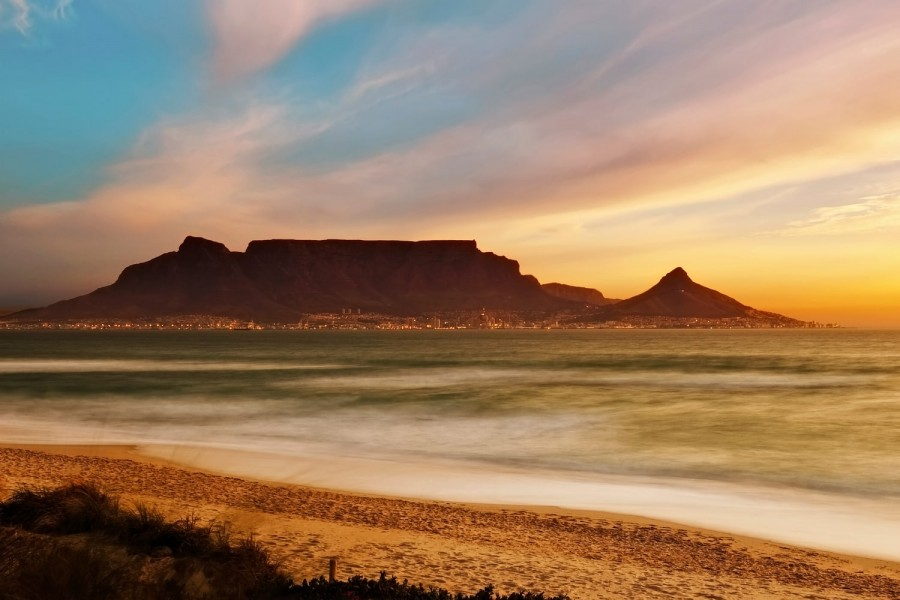What might be the story of the people who left the footprints on the sand? The footprints on the sand tell a quiet, unfolding story of a couple who came to the beach for an evening walk. Hand in hand, they strolled along the shore, talking softly and enjoying each other's company. They were met with the cool, gentle breeze that carried with it the smell of the sea. The man, a photographer, came to capture the sunset as it painted the sky in shades of orange and purple. He paused often, leaving behind deeper impressions in the sand as he set his camera for the perfect shot. The woman, a writer, gathered inspiration from the picturesque scenery and the sounds around her. She occasionally bent down to pick up a unique shell or a smooth stone, contemplating its story as the ocean waves played a soothing symphony. Together, they left a trail of intertwined footprints, a memento of their shared moment amidst the serene beauty of Table Mountain's overlooking presence and the calm ocean.  On a clear day, what might one expect to see from the top of Table Mountain? On a clear day, the view from the top of Table Mountain would be nothing short of breathtaking. One would see the sprawling city of Cape Town below, with its mix of modern skyscrapers and historical buildings lining the streets. The coastline stretches out in both directions, revealing pristine beaches and the deep blue expanse of the Atlantic Ocean. To one side, the iconic shape of Lion's Head and Signal Hill stands out, adding to the diverse landscape. Farther out, the Robben Island can be seen, its historical significance as a World Heritage Site adding a layer of depth to the view. The horizon meets the sky in a seemingly endless tango of blue. It’s a vantage point that offers a panoramic sweep of the natural and urban beauty, capturing the essence of Cape Town and its surroundings. 